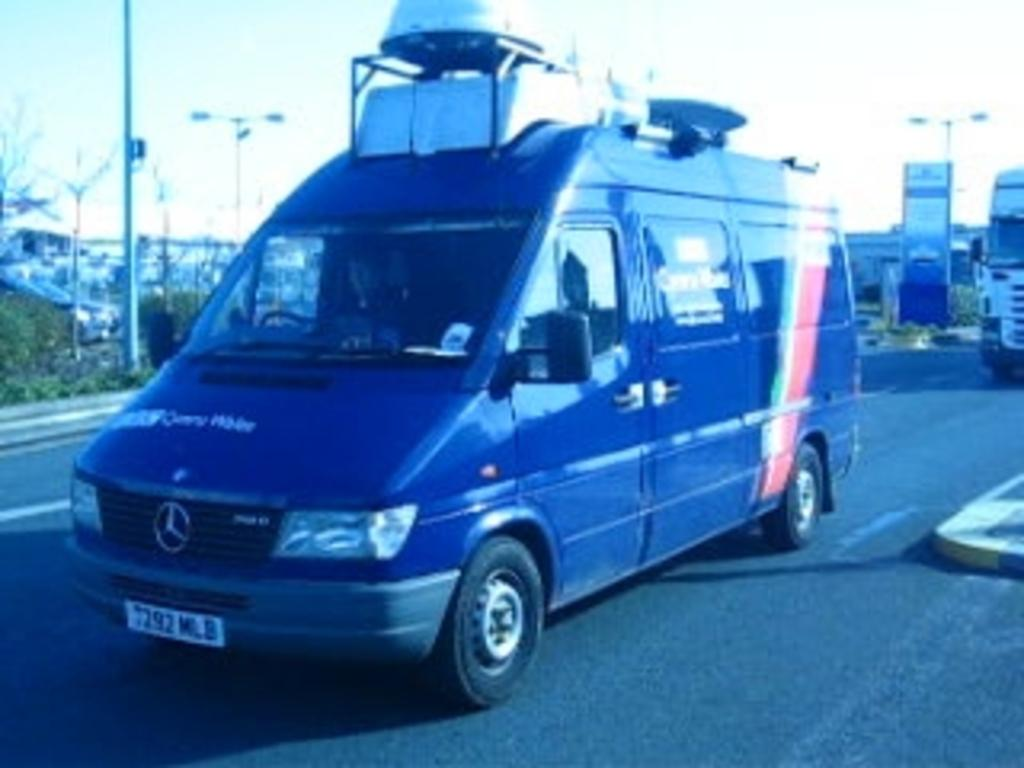<image>
Give a short and clear explanation of the subsequent image. A blue Mercedes van with the plate 7292 MLB on the front. 